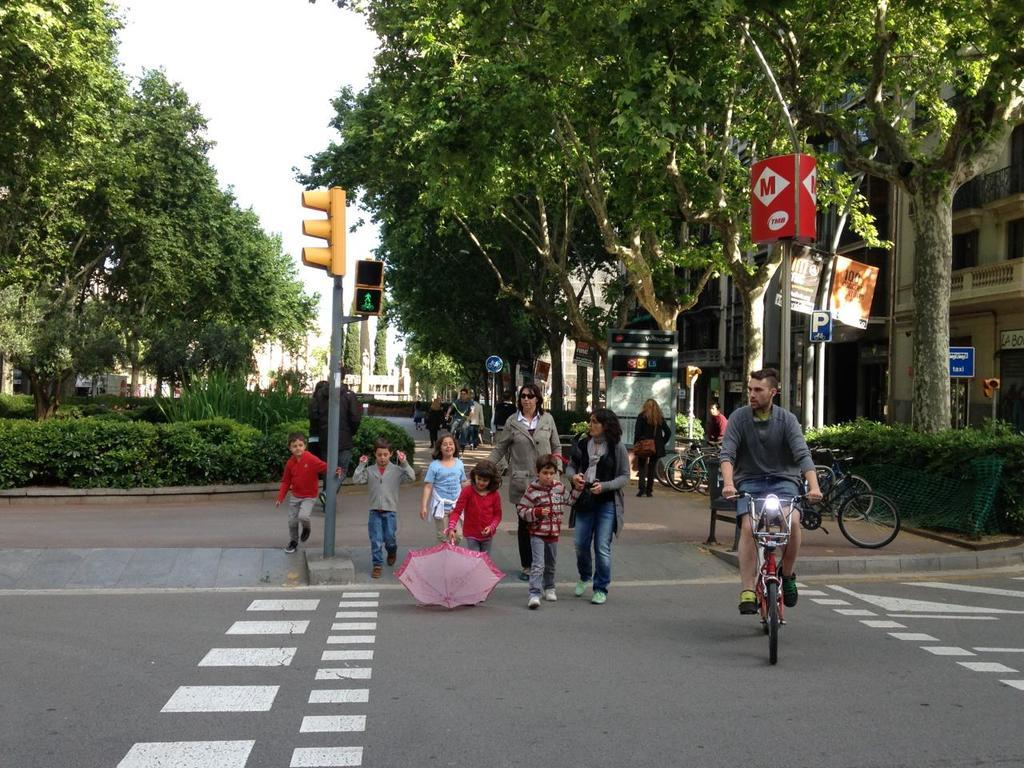<image>
Provide a brief description of the given image. A young girl is dragging a pink umbrella on the road, while passing a red sign, on the top of a pole, that has the letters TMB on it. 